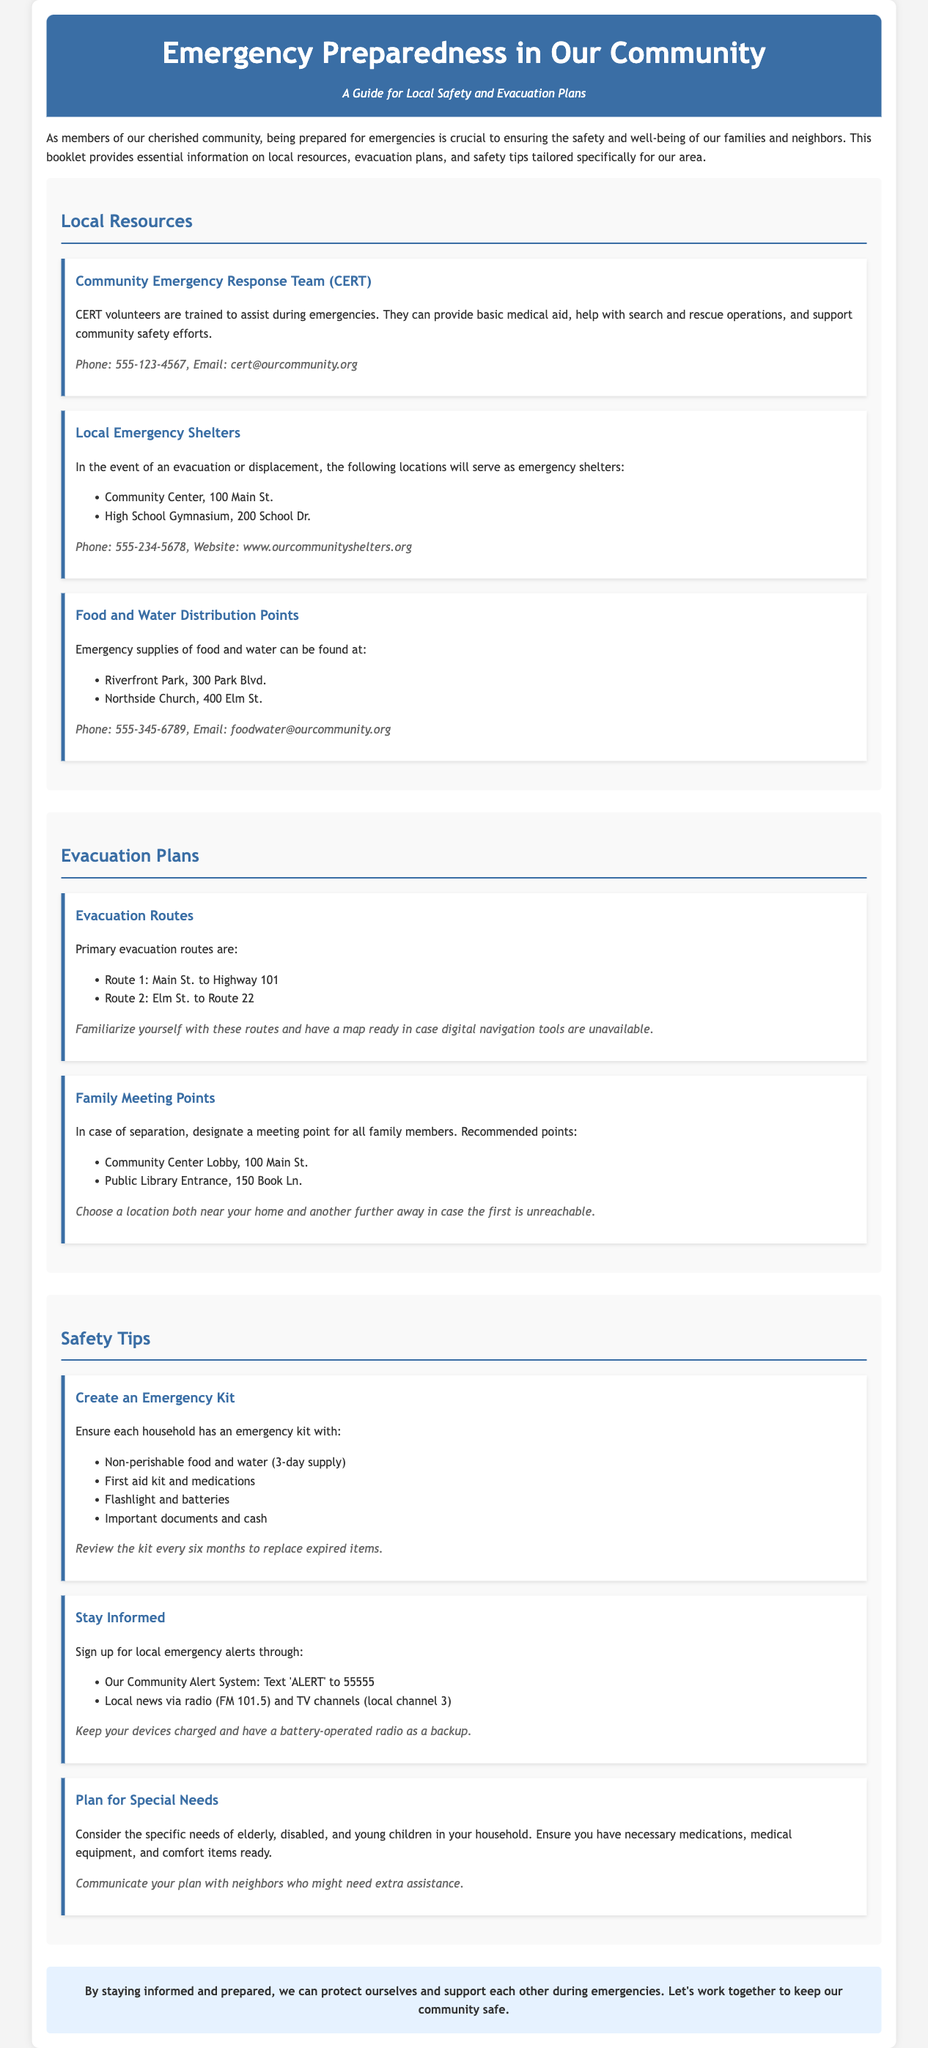what is the phone number for the Community Emergency Response Team? The phone number can be found in the local resources section under CERT.
Answer: 555-123-4567 what are the two locations identified as emergency shelters? These locations are listed under the local resources section for emergency shelters.
Answer: Community Center, High School Gymnasium what supplies should be in an emergency kit? The contents of the emergency kit are outlined in the safety tips section.
Answer: Non-perishable food, water, first aid kit, flashlight, important documents how can community members stay informed during emergencies? The document provides methods to stay informed under the safety tips section.
Answer: Local emergency alerts, local news what should families do in case of separation during an evacuation? The document advises families on this topic in the evacuation plans section.
Answer: Designate a meeting point what is the primary evacuation route mentioned in the document? The evacuation route is listed in the evacuation plans section.
Answer: Main St. to Highway 101 how often should you review your emergency kit? This detail is mentioned in the safety tips section regarding the emergency kit.
Answer: Every six months which church is a food and water distribution point? The specific location is mentioned in the local resources section under food and water distribution.
Answer: Northside Church 